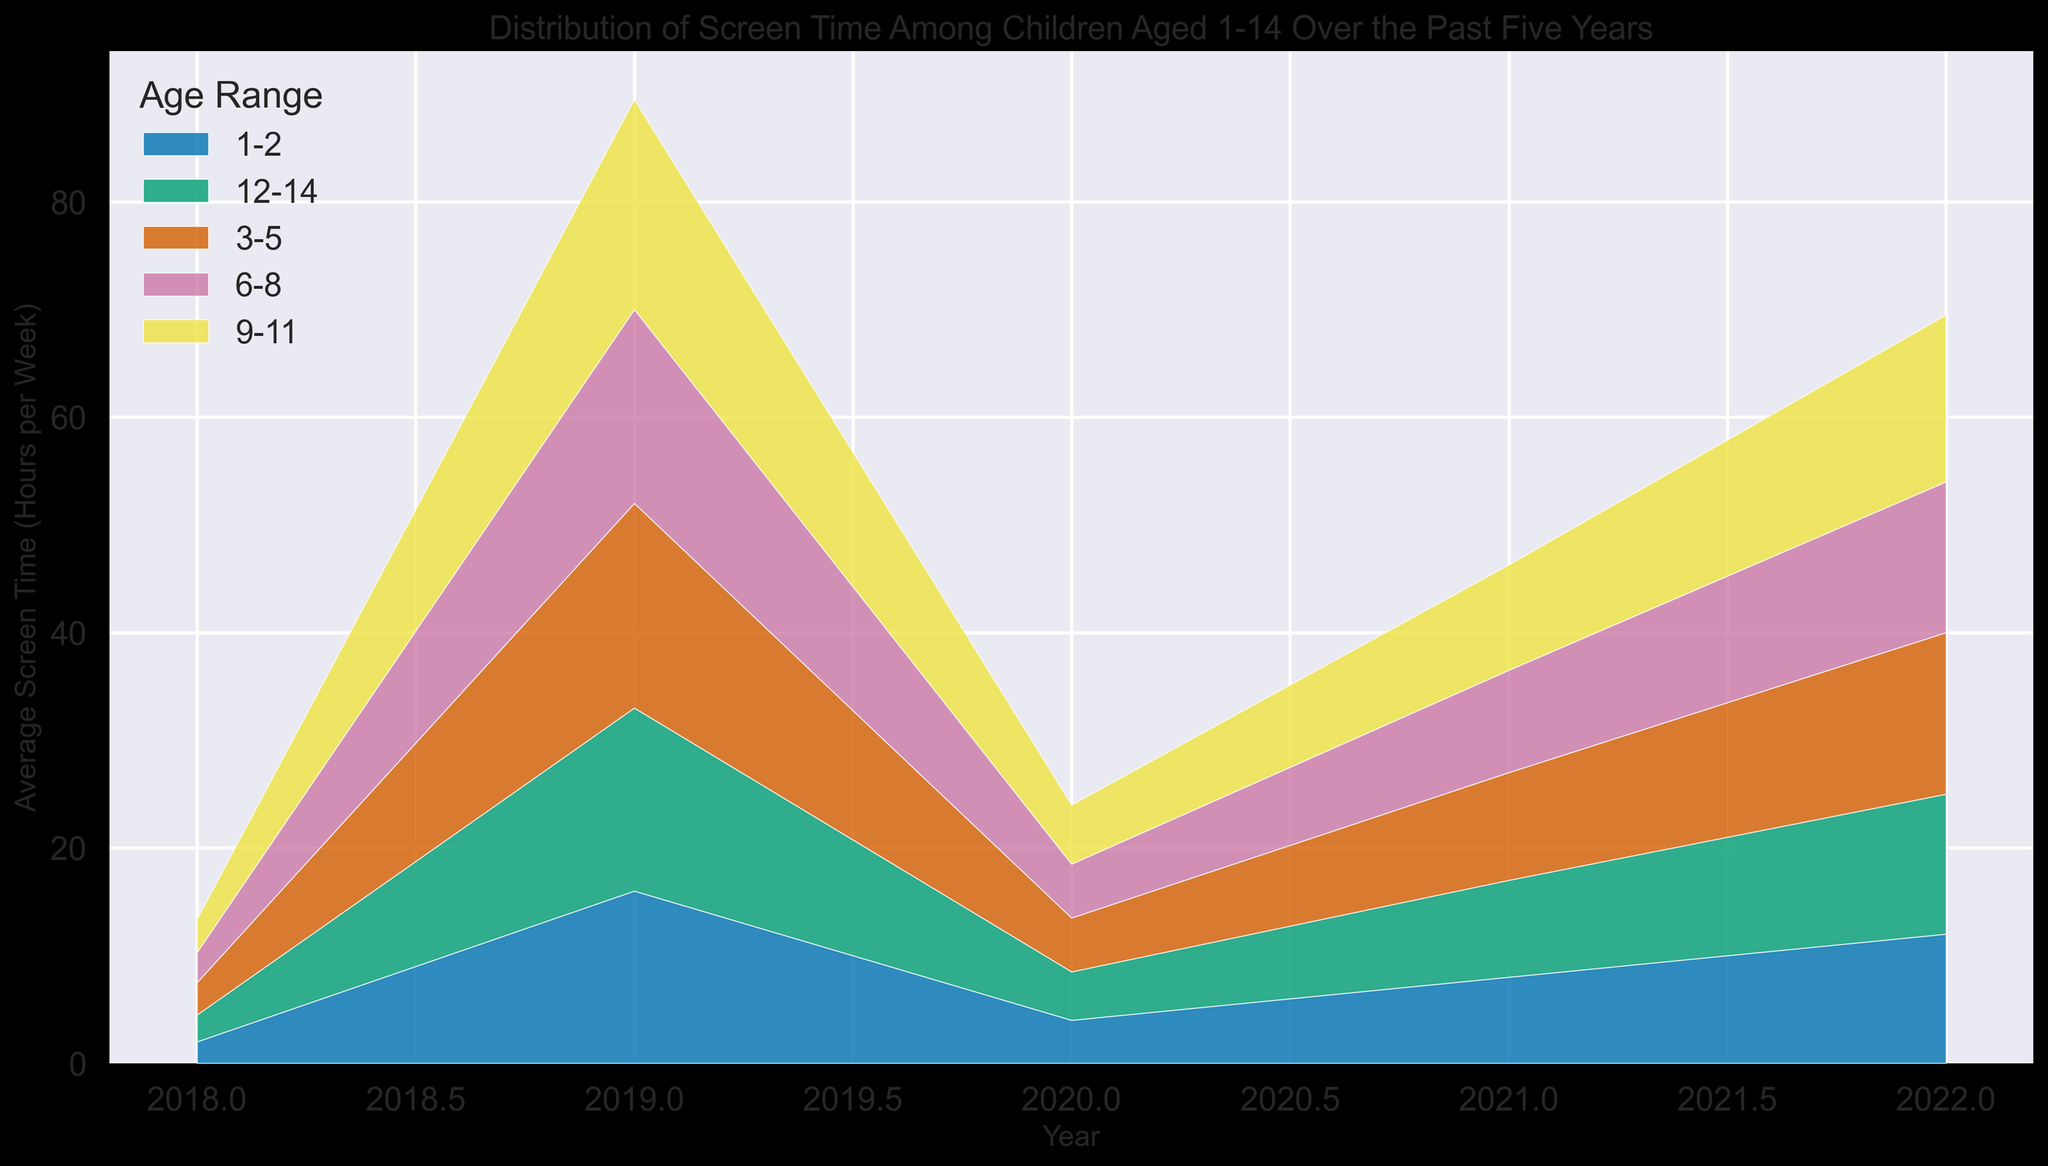What trend do you see in the average screen time for children aged 6-8 years over the five years? The average screen time for children aged 6-8 years has generally increased from 2018 to 2022. Starting from about 8 hours per week in 2018, it gradually rose to approximately 9.8 hours per week by 2022.
Answer: It increased Which age range saw the highest average screen time in 2020, and how many hours was it? In 2020, children aged 12-14 years had the highest average screen time of 19 hours per week. This can be observed from the topmost area in the stack plot for that year.
Answer: 12-14, 19 hours What is the difference in average screen time for children aged 1-2 years between 2018 and 2022? The average screen time for children aged 1-2 years was 2 hours in 2018 and increased to 3.1 hours in 2022. The difference is 3.1 - 2 = 1.1 hours.
Answer: 1.1 hours Between which years did the average screen time for children aged 9-11 years see the largest increase, and how much was the increase? The average screen time for children aged 9-11 years increased the most between 2019 and 2020, rising from 13 hours to 15 hours per week. The increase is 15 - 13 = 2 hours.
Answer: 2019-2020, 2 hours Compare the average screen time of children aged 3-5 years in 2020 to that in 2021. Is there any change? In 2020, the average screen time for children aged 3-5 years was 5 hours per week. In 2021, it remained the same at 5 hours per week. Thus, there was no change.
Answer: No change What is the total average screen time for all age groups combined in 2019? The total average screen time in 2019 is the sum of screen times across all age groups: 2.5 (1-2 years) + 4.5 (3-5 years) + 9 (6-8 years) + 13 (9-11 years) + 17 (12-14 years) = 46 hours.
Answer: 46 hours By how much did the average screen time for children aged 12-14 years change between 2021 and 2022? The average screen time for children aged 12-14 years was 18 hours in 2021 and increased to 19.5 hours in 2022. The change is 19.5 - 18 = 1.5 hours.
Answer: 1.5 hours Which age range had the smallest change in average screen time from 2018 to 2022? The age range 1-2 years had the smallest change in average screen time, from 2 hours in 2018 to 3.1 hours in 2022, representing a 1.1-hour difference. This is the smallest change among all age groups.
Answer: 1-2 years Compare the trend of average screen time for children aged 9-11 years to that of those aged 3-5 years. For children aged 9-11 years, the average screen time consistently increased each year from 2018 to 2022. Similarly, children aged 3-5 years also showed an upward trend over the same period. However, the increase in screen time for 9-11 years old was more significant compared to 3-5 years old.
Answer: Both increased, but 9-11 years had a more significant increase 